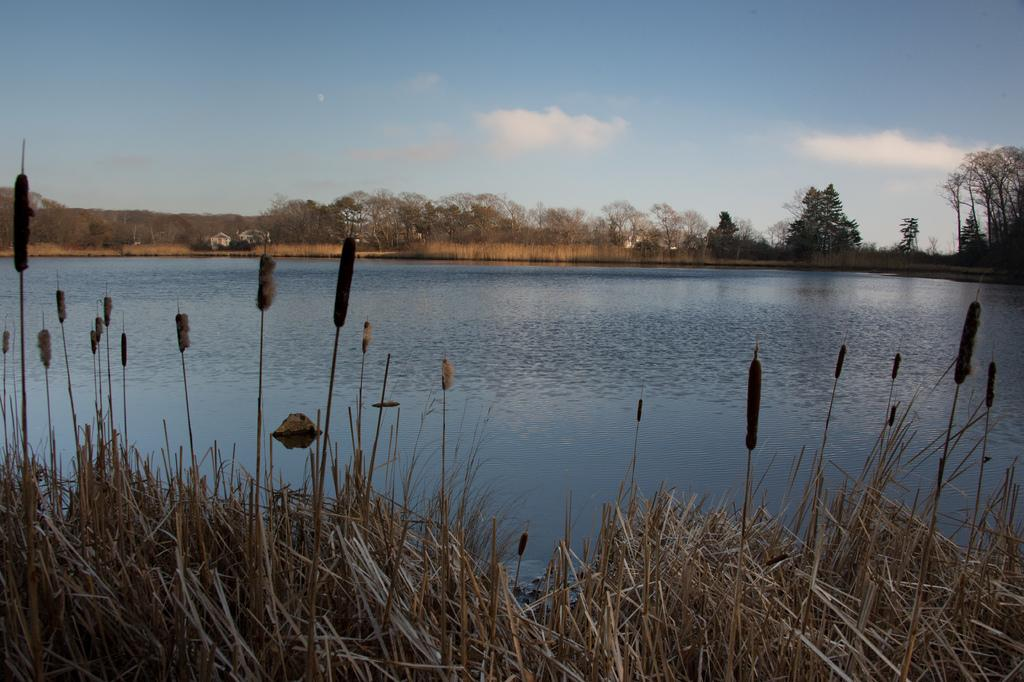What is the primary element visible in the image? There is water in the image. What can be seen in the distance behind the water? There are trees visible in the background. How would you describe the weather based on the image? The sky is sunny in the image, suggesting a clear and bright day. How many children are standing in the middle of the water in the image? There are no children present in the image; it only features water and trees in the background. 